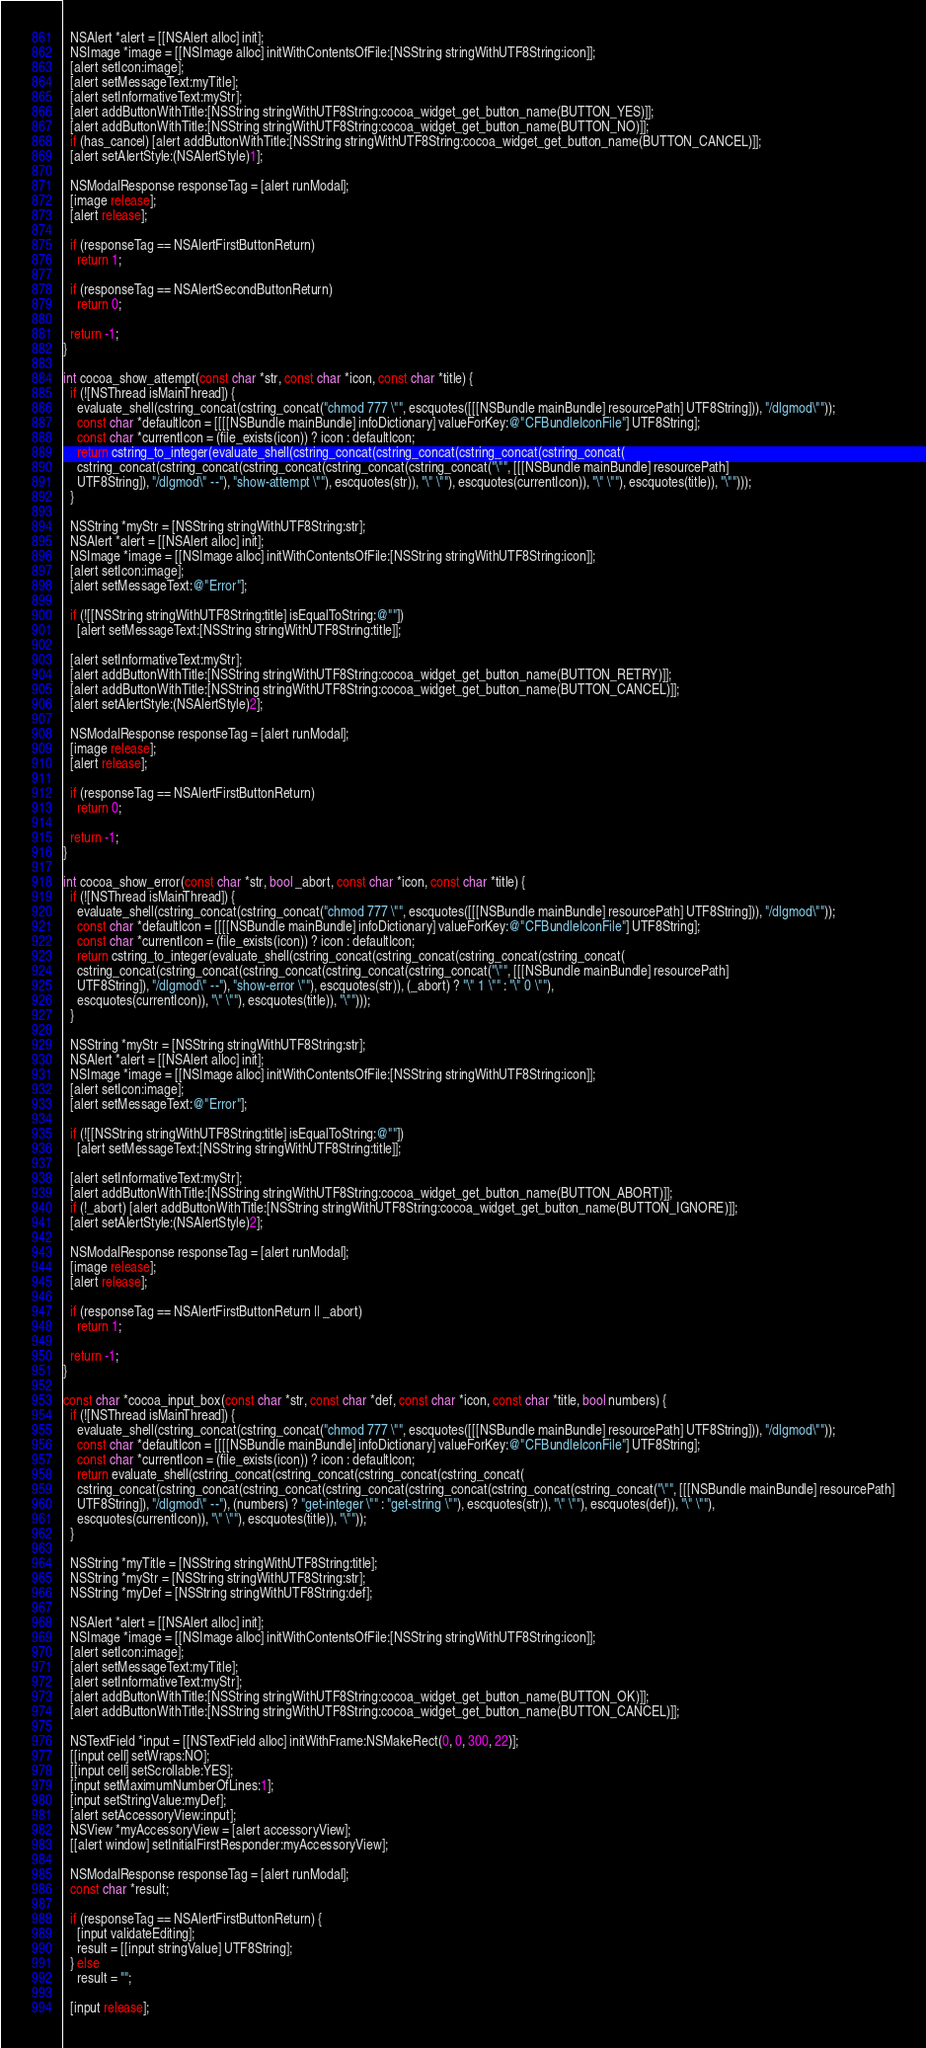Convert code to text. <code><loc_0><loc_0><loc_500><loc_500><_ObjectiveC_>
  NSAlert *alert = [[NSAlert alloc] init];
  NSImage *image = [[NSImage alloc] initWithContentsOfFile:[NSString stringWithUTF8String:icon]];
  [alert setIcon:image];
  [alert setMessageText:myTitle];
  [alert setInformativeText:myStr];
  [alert addButtonWithTitle:[NSString stringWithUTF8String:cocoa_widget_get_button_name(BUTTON_YES)]];
  [alert addButtonWithTitle:[NSString stringWithUTF8String:cocoa_widget_get_button_name(BUTTON_NO)]];
  if (has_cancel) [alert addButtonWithTitle:[NSString stringWithUTF8String:cocoa_widget_get_button_name(BUTTON_CANCEL)]];
  [alert setAlertStyle:(NSAlertStyle)1];

  NSModalResponse responseTag = [alert runModal];
  [image release];
  [alert release];

  if (responseTag == NSAlertFirstButtonReturn)
    return 1;

  if (responseTag == NSAlertSecondButtonReturn)
    return 0;

  return -1;
}

int cocoa_show_attempt(const char *str, const char *icon, const char *title) {
  if (![NSThread isMainThread]) {
    evaluate_shell(cstring_concat(cstring_concat("chmod 777 \"", escquotes([[[NSBundle mainBundle] resourcePath] UTF8String])), "/dlgmod\""));
    const char *defaultIcon = [[[[NSBundle mainBundle] infoDictionary] valueForKey:@"CFBundleIconFile"] UTF8String];
    const char *currentIcon = (file_exists(icon)) ? icon : defaultIcon;
    return cstring_to_integer(evaluate_shell(cstring_concat(cstring_concat(cstring_concat(cstring_concat(
    cstring_concat(cstring_concat(cstring_concat(cstring_concat(cstring_concat("\"", [[[NSBundle mainBundle] resourcePath]
    UTF8String]), "/dlgmod\" --"), "show-attempt \""), escquotes(str)), "\" \""), escquotes(currentIcon)), "\" \""), escquotes(title)), "\"")));
  }

  NSString *myStr = [NSString stringWithUTF8String:str];
  NSAlert *alert = [[NSAlert alloc] init];
  NSImage *image = [[NSImage alloc] initWithContentsOfFile:[NSString stringWithUTF8String:icon]];
  [alert setIcon:image];
  [alert setMessageText:@"Error"];

  if (![[NSString stringWithUTF8String:title] isEqualToString:@""])
    [alert setMessageText:[NSString stringWithUTF8String:title]];

  [alert setInformativeText:myStr];
  [alert addButtonWithTitle:[NSString stringWithUTF8String:cocoa_widget_get_button_name(BUTTON_RETRY)]];
  [alert addButtonWithTitle:[NSString stringWithUTF8String:cocoa_widget_get_button_name(BUTTON_CANCEL)]];
  [alert setAlertStyle:(NSAlertStyle)2];

  NSModalResponse responseTag = [alert runModal];
  [image release];
  [alert release];

  if (responseTag == NSAlertFirstButtonReturn)
    return 0;

  return -1;
}

int cocoa_show_error(const char *str, bool _abort, const char *icon, const char *title) {
  if (![NSThread isMainThread]) {
    evaluate_shell(cstring_concat(cstring_concat("chmod 777 \"", escquotes([[[NSBundle mainBundle] resourcePath] UTF8String])), "/dlgmod\""));
    const char *defaultIcon = [[[[NSBundle mainBundle] infoDictionary] valueForKey:@"CFBundleIconFile"] UTF8String];
    const char *currentIcon = (file_exists(icon)) ? icon : defaultIcon;
    return cstring_to_integer(evaluate_shell(cstring_concat(cstring_concat(cstring_concat(cstring_concat(
    cstring_concat(cstring_concat(cstring_concat(cstring_concat(cstring_concat("\"", [[[NSBundle mainBundle] resourcePath]
    UTF8String]), "/dlgmod\" --"), "show-error \""), escquotes(str)), (_abort) ? "\" 1 \"" : "\" 0 \""),
    escquotes(currentIcon)), "\" \""), escquotes(title)), "\"")));
  }

  NSString *myStr = [NSString stringWithUTF8String:str];
  NSAlert *alert = [[NSAlert alloc] init];
  NSImage *image = [[NSImage alloc] initWithContentsOfFile:[NSString stringWithUTF8String:icon]];
  [alert setIcon:image];
  [alert setMessageText:@"Error"];

  if (![[NSString stringWithUTF8String:title] isEqualToString:@""])
    [alert setMessageText:[NSString stringWithUTF8String:title]];

  [alert setInformativeText:myStr];
  [alert addButtonWithTitle:[NSString stringWithUTF8String:cocoa_widget_get_button_name(BUTTON_ABORT)]];
  if (!_abort) [alert addButtonWithTitle:[NSString stringWithUTF8String:cocoa_widget_get_button_name(BUTTON_IGNORE)]];
  [alert setAlertStyle:(NSAlertStyle)2];

  NSModalResponse responseTag = [alert runModal];
  [image release];
  [alert release];

  if (responseTag == NSAlertFirstButtonReturn || _abort)
    return 1;

  return -1;
}

const char *cocoa_input_box(const char *str, const char *def, const char *icon, const char *title, bool numbers) {
  if (![NSThread isMainThread]) {
    evaluate_shell(cstring_concat(cstring_concat("chmod 777 \"", escquotes([[[NSBundle mainBundle] resourcePath] UTF8String])), "/dlgmod\""));
    const char *defaultIcon = [[[[NSBundle mainBundle] infoDictionary] valueForKey:@"CFBundleIconFile"] UTF8String];
    const char *currentIcon = (file_exists(icon)) ? icon : defaultIcon;
    return evaluate_shell(cstring_concat(cstring_concat(cstring_concat(cstring_concat(
    cstring_concat(cstring_concat(cstring_concat(cstring_concat(cstring_concat(cstring_concat(cstring_concat("\"", [[[NSBundle mainBundle] resourcePath]
    UTF8String]), "/dlgmod\" --"), (numbers) ? "get-integer \"" : "get-string \""), escquotes(str)), "\" \""), escquotes(def)), "\" \""),
    escquotes(currentIcon)), "\" \""), escquotes(title)), "\""));
  }

  NSString *myTitle = [NSString stringWithUTF8String:title];
  NSString *myStr = [NSString stringWithUTF8String:str];
  NSString *myDef = [NSString stringWithUTF8String:def];

  NSAlert *alert = [[NSAlert alloc] init];
  NSImage *image = [[NSImage alloc] initWithContentsOfFile:[NSString stringWithUTF8String:icon]];
  [alert setIcon:image];
  [alert setMessageText:myTitle];
  [alert setInformativeText:myStr];
  [alert addButtonWithTitle:[NSString stringWithUTF8String:cocoa_widget_get_button_name(BUTTON_OK)]];
  [alert addButtonWithTitle:[NSString stringWithUTF8String:cocoa_widget_get_button_name(BUTTON_CANCEL)]];

  NSTextField *input = [[NSTextField alloc] initWithFrame:NSMakeRect(0, 0, 300, 22)];
  [[input cell] setWraps:NO];
  [[input cell] setScrollable:YES];
  [input setMaximumNumberOfLines:1];
  [input setStringValue:myDef];
  [alert setAccessoryView:input];
  NSView *myAccessoryView = [alert accessoryView];
  [[alert window] setInitialFirstResponder:myAccessoryView];

  NSModalResponse responseTag = [alert runModal];
  const char *result;

  if (responseTag == NSAlertFirstButtonReturn) {
    [input validateEditing];
    result = [[input stringValue] UTF8String];
  } else
    result = "";

  [input release];</code> 